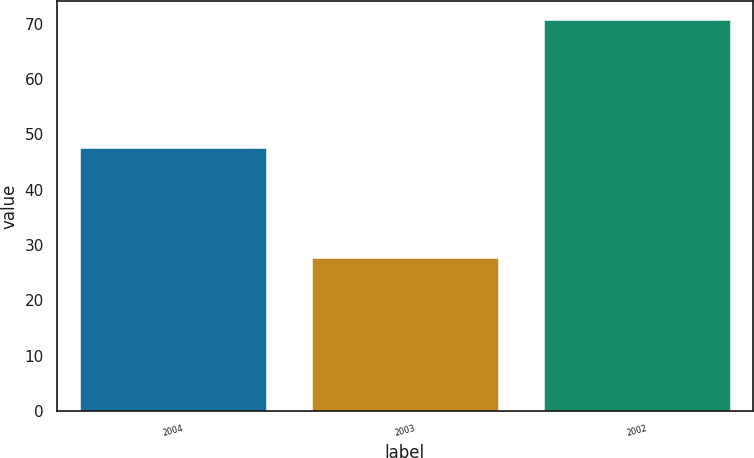Convert chart to OTSL. <chart><loc_0><loc_0><loc_500><loc_500><bar_chart><fcel>2004<fcel>2003<fcel>2002<nl><fcel>47.6<fcel>27.6<fcel>70.6<nl></chart> 